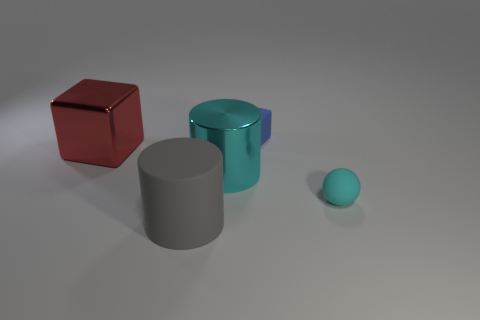Are there any other things that are the same shape as the cyan rubber thing?
Ensure brevity in your answer.  No. There is a small matte thing that is in front of the small rubber cube; what shape is it?
Your answer should be compact. Sphere. Are the cyan ball and the cyan thing that is behind the cyan ball made of the same material?
Keep it short and to the point. No. Are there any metal cylinders?
Make the answer very short. Yes. Is there a small matte thing right of the block to the right of the shiny thing that is in front of the red shiny cube?
Provide a succinct answer. Yes. How many big things are gray rubber cubes or cyan spheres?
Your response must be concise. 0. There is another metal cylinder that is the same size as the gray cylinder; what color is it?
Give a very brief answer. Cyan. How many rubber spheres are to the right of the big cube?
Offer a very short reply. 1. Are there any big gray things that have the same material as the small cube?
Your answer should be compact. Yes. What is the shape of the big metallic object that is the same color as the tiny sphere?
Offer a terse response. Cylinder. 